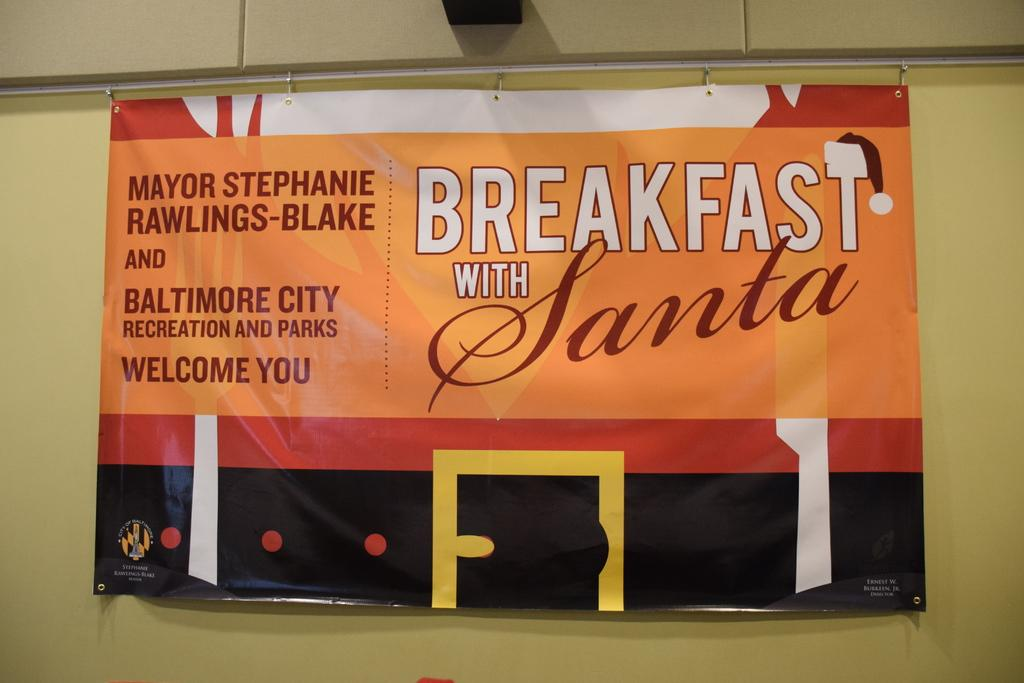<image>
Write a terse but informative summary of the picture. the word breakfast that is on a sign 